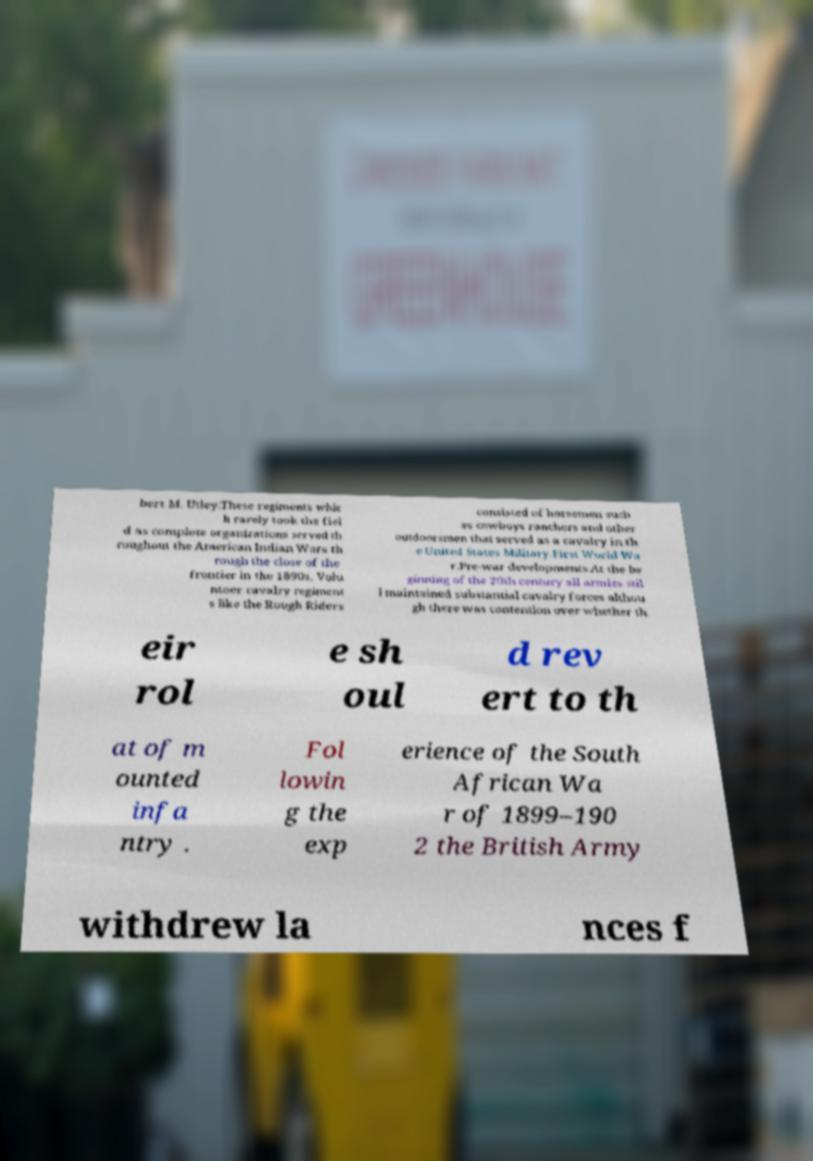There's text embedded in this image that I need extracted. Can you transcribe it verbatim? bert M. Utley:These regiments whic h rarely took the fiel d as complete organizations served th roughout the American Indian Wars th rough the close of the frontier in the 1890s. Volu nteer cavalry regiment s like the Rough Riders consisted of horsemen such as cowboys ranchers and other outdoorsmen that served as a cavalry in th e United States Military.First World Wa r.Pre-war developments.At the be ginning of the 20th century all armies stil l maintained substantial cavalry forces althou gh there was contention over whether th eir rol e sh oul d rev ert to th at of m ounted infa ntry . Fol lowin g the exp erience of the South African Wa r of 1899–190 2 the British Army withdrew la nces f 